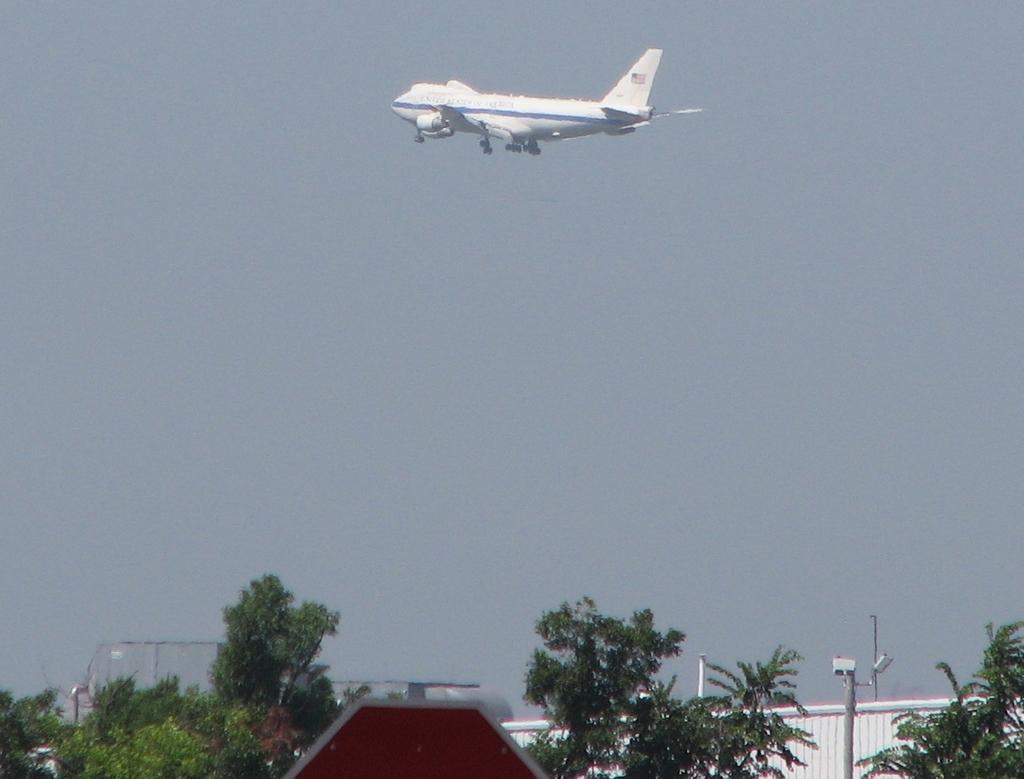In one or two sentences, can you explain what this image depicts? In the picture I can see an aeroplane is flying in the air. I can also see trees, poles and some other objects. In the background I can see the sky. 